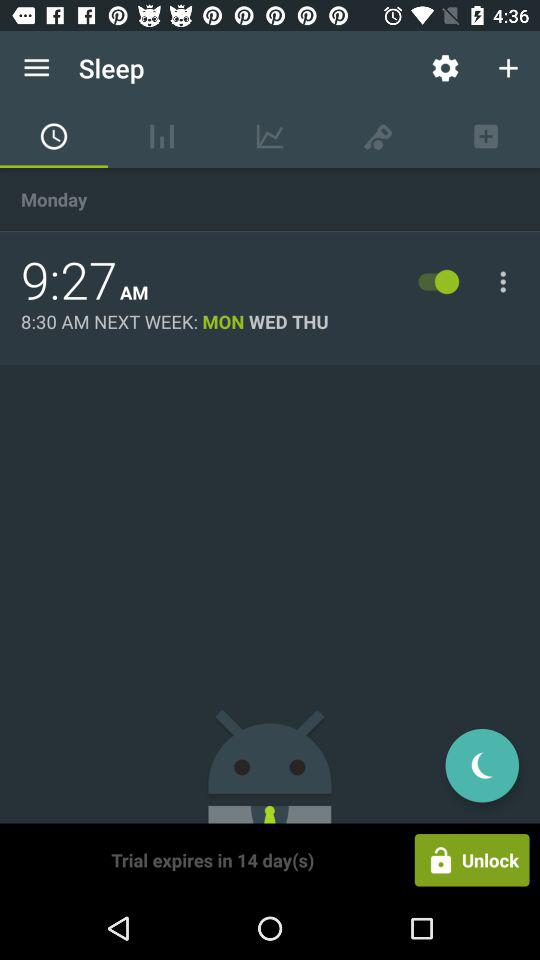For which days is the sleep alarm set? The sleep alarm is set for Monday, Wednesday and Thursday. 